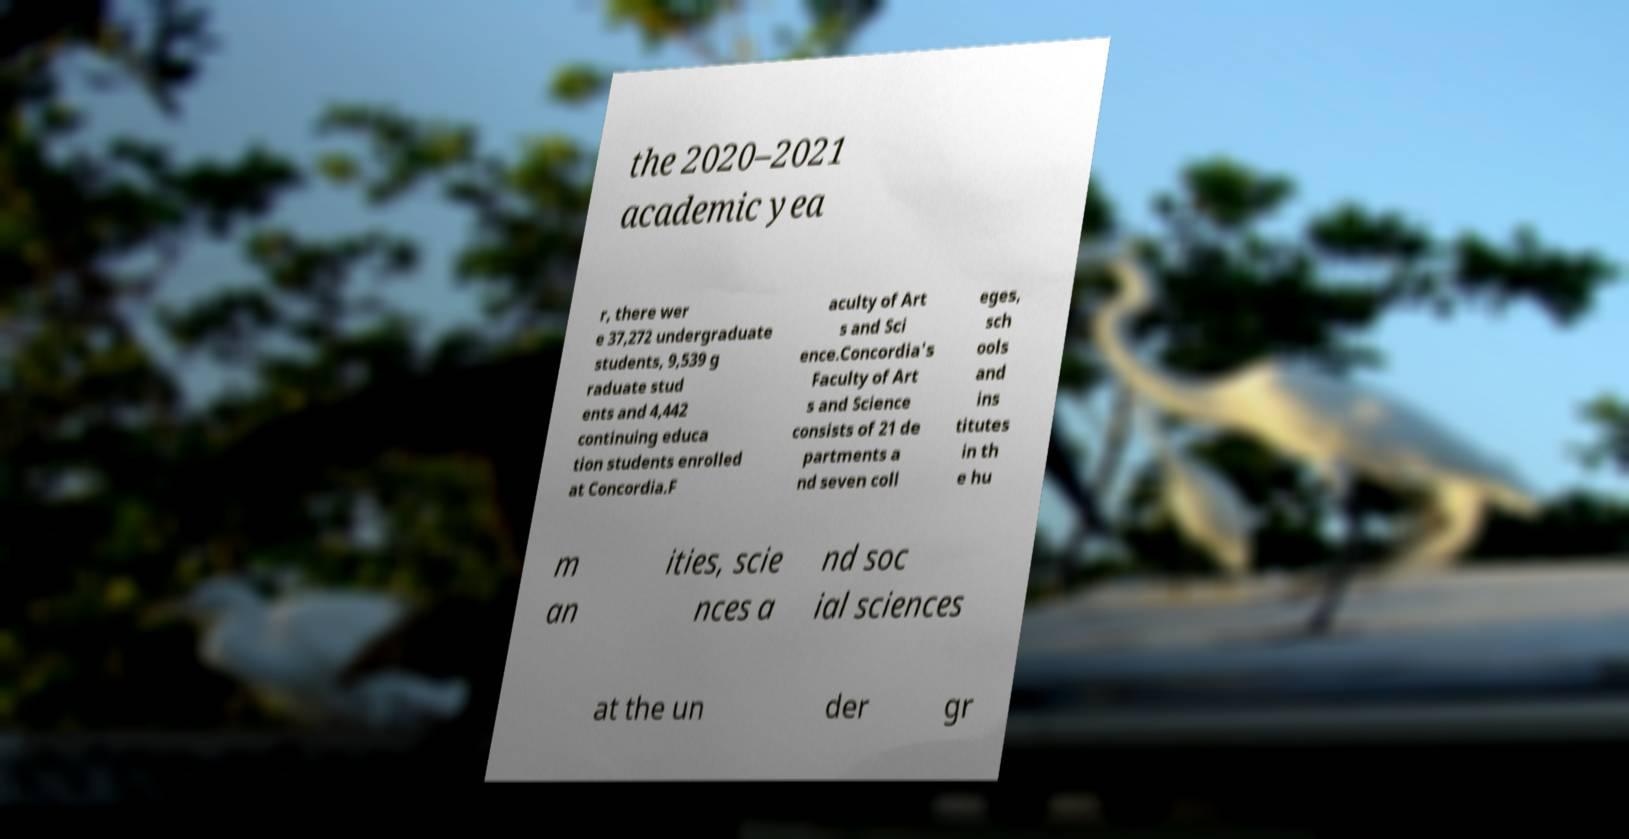Could you extract and type out the text from this image? the 2020–2021 academic yea r, there wer e 37,272 undergraduate students, 9,539 g raduate stud ents and 4,442 continuing educa tion students enrolled at Concordia.F aculty of Art s and Sci ence.Concordia's Faculty of Art s and Science consists of 21 de partments a nd seven coll eges, sch ools and ins titutes in th e hu m an ities, scie nces a nd soc ial sciences at the un der gr 